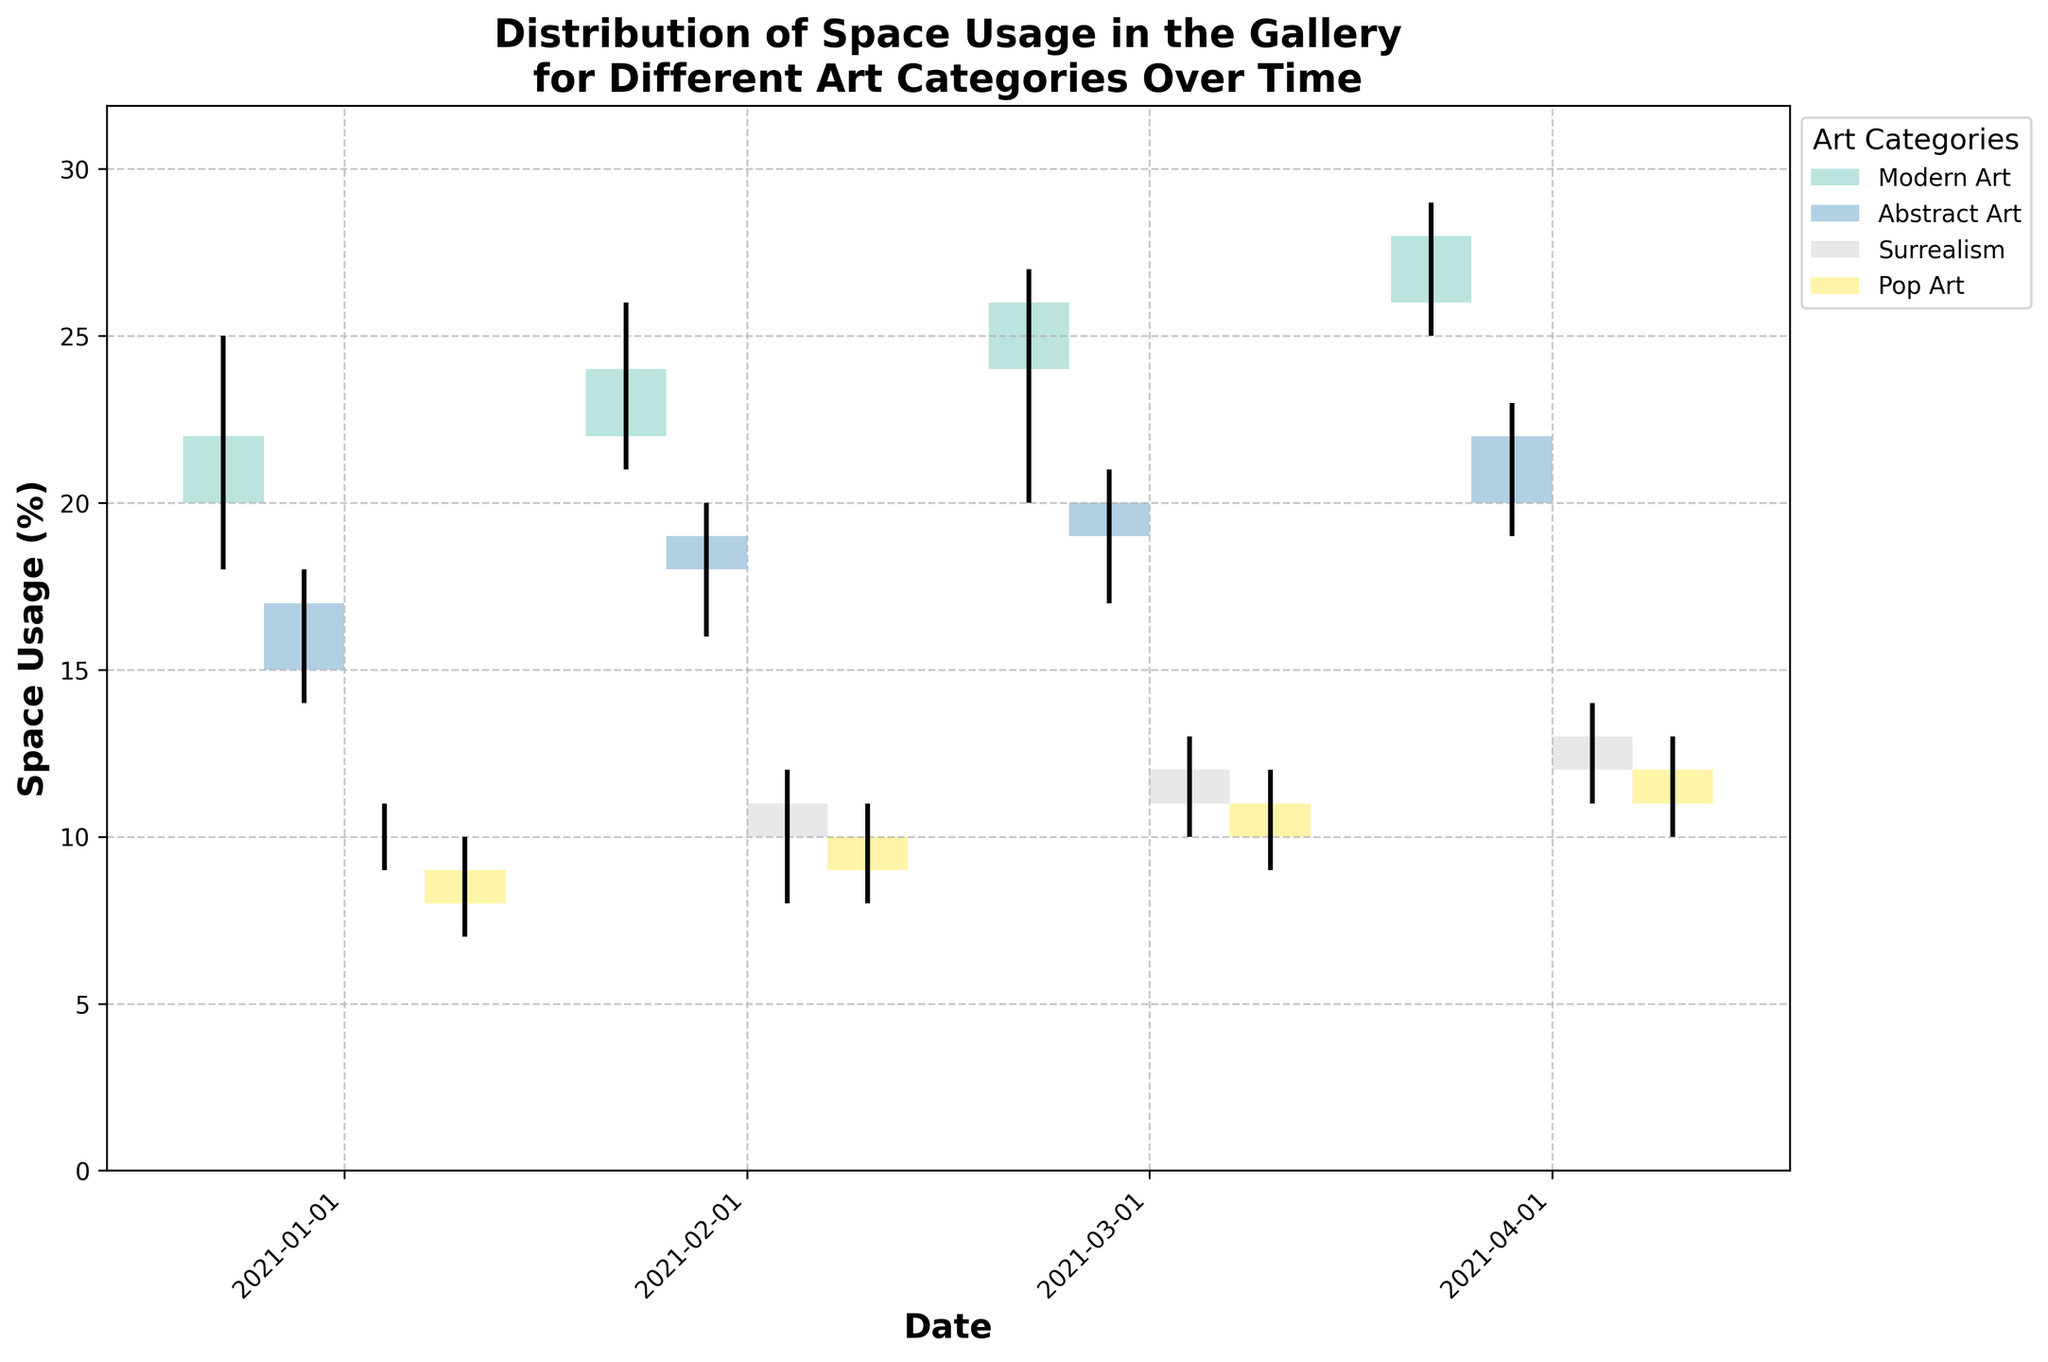Which art category had the highest space usage in April 2021? To find the highest space usage, identify the category with the tallest bar for April 2021. Modern Art has the tallest bar in April 2021.
Answer: Modern Art What is the total variation in space usage for Abstract Art in January 2021? The total variation is calculated by subtracting the lowest value from the highest value, which is 18 - 14 for Abstract Art in January 2021. The difference is 4.
Answer: 4 Which art category shows the smallest increase in space usage from February to March 2021? Calculate the difference between the 'Close' values of March and February for each category. Surrealism has the smallest increase: March (12) - February (11) = 1.
Answer: Surrealism By what percentage did the space usage of Modern Art increase from January to April 2021? Calculate the percentage increase using the formula: ((Close in April - Close in January) / Close in January) * 100. For Modern Art: ((28 - 22) / 22) * 100 ≈ 27.3%.
Answer: 27.3% Which dates have the same 'Close' value for Surrealism? Check the 'Close' values of Surrealism across all dates. Both January (10) and February (11) have different values, but March and April both have 12. So, no dates have the same 'Close' value for Surrealism.
Answer: None How many art categories showed an increase in space usage from January to February 2021? Check the 'Close' values from January to February for each category. All categories (Modern Art, Abstract Art, Surrealism, Pop Art) show an increase.
Answer: 4 Which art category had the highest volatility in space usage in April 2021? Volatility is measured by the range (High - Low). Modern Art in April 2021 has the highest range: 29 - 25 = 4.
Answer: Modern Art What is the combined Open value for all art categories in March 2021? Sum the 'Open' values for March 2021: Modern Art (24) + Abstract Art (19) + Surrealism (11) + Pop Art (10) = 64.
Answer: 64 Which category had the most steady space usage in the first quarter of 2021? Steadiness can be inferred from small variations between periods. Surrealism maintains the smallest variations overall.
Answer: Surrealism 